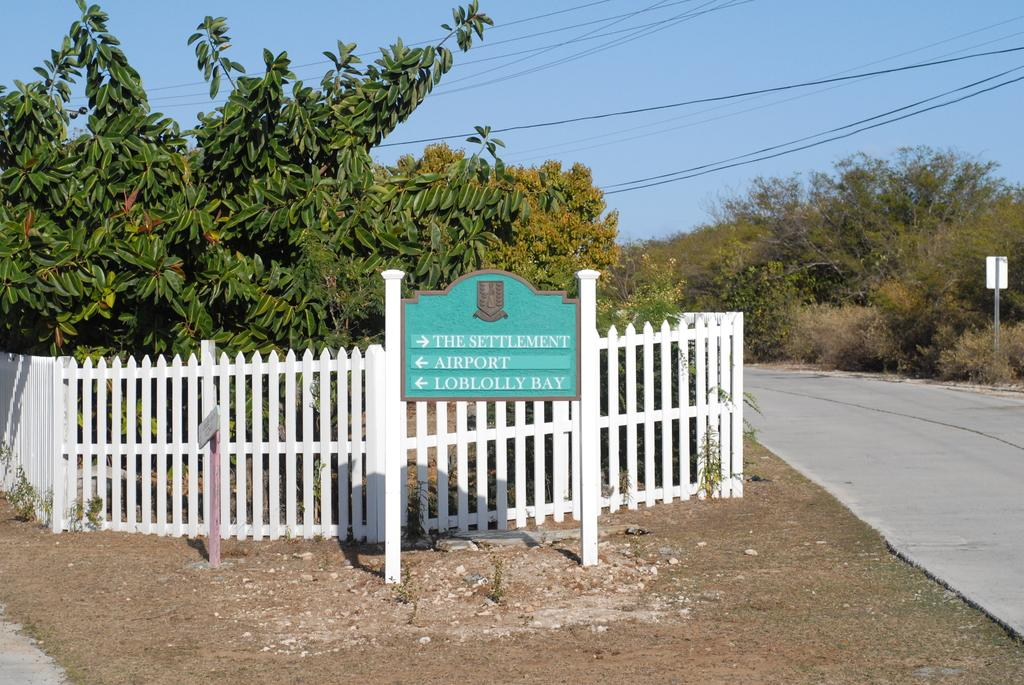What type of structures can be seen in the image? There are boards and a fence in the image. What natural elements are present in the image? There are trees in the image. What man-made elements are present in the image? There are cables and a road in the image. What can be seen in the background of the image? The sky is visible in the background of the image. What type of chance is being taken by the person riding the bike in the image? There is no bike present in the image, so no one is taking a chance by riding a bike. What type of magic is being performed by the trees in the image? There is no magic being performed by the trees in the image; they are simply trees. 